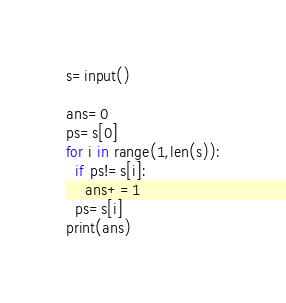Convert code to text. <code><loc_0><loc_0><loc_500><loc_500><_Python_>s=input()

ans=0
ps=s[0]
for i in range(1,len(s)):
  if ps!=s[i]:
    ans+=1
  ps=s[i]
print(ans)
</code> 